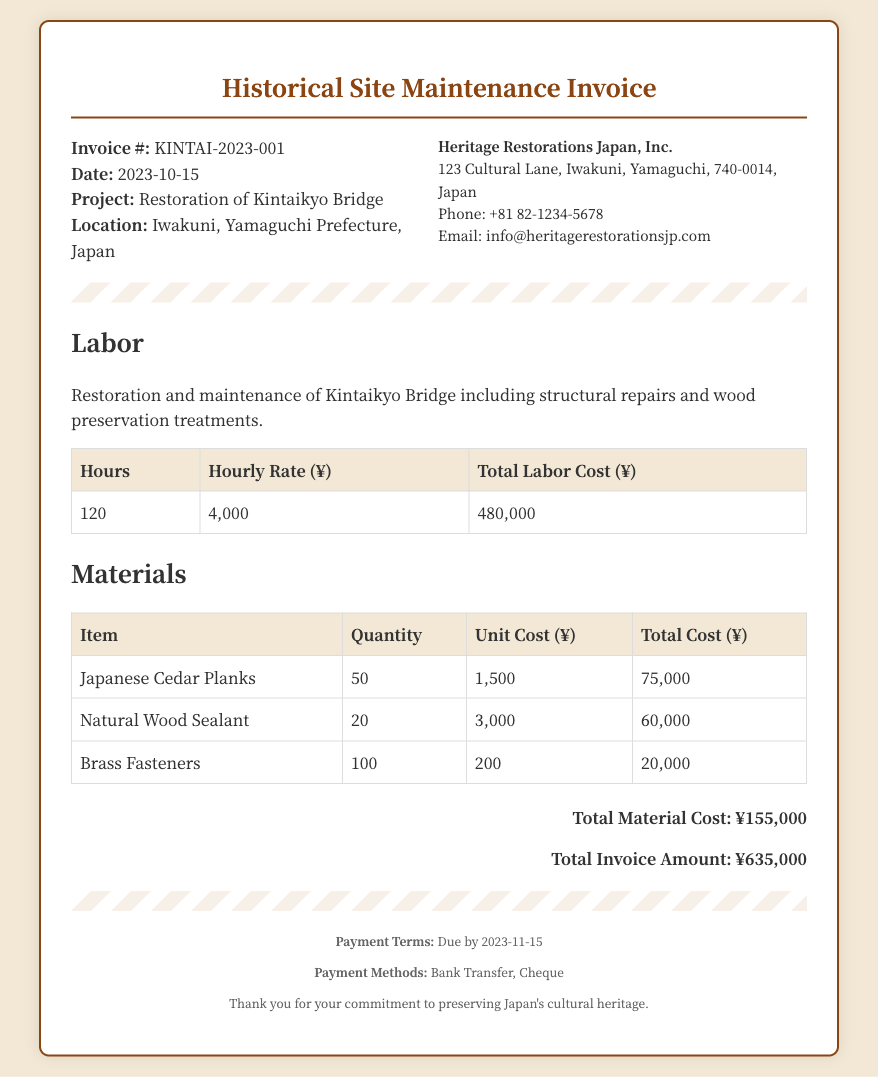What is the invoice number? The invoice number is listed prominently under the invoice header.
Answer: KINTAI-2023-001 What is the total labor cost? The total labor cost is provided in the labor section of the document.
Answer: 480,000 How many Japanese Cedar Planks were purchased? The quantity of Japanese Cedar Planks can be found in the materials table.
Answer: 50 What is the total invoice amount? The total invoice amount is summarized at the bottom of the document.
Answer: ¥635,000 What is the hourly rate for labor? The hourly rate for labor is specified in the labor section of the invoice.
Answer: 4,000 Who is the contractor for this project? The contractor's details are listed in the contractor info section.
Answer: Heritage Restorations Japan, Inc What is the due date for payment? The payment terms include the due date, which is mentioned in the footer.
Answer: 2023-11-15 What payment methods are accepted? The footer outlines acceptable payment methods for the invoice.
Answer: Bank Transfer, Cheque What type of wood treatment was included in the restoration? The labor description specifies the types of work performed on the bridge.
Answer: Wood preservation treatments 